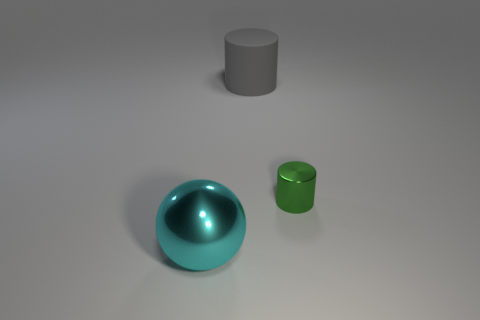How many large objects are either cyan shiny balls or red shiny blocks?
Make the answer very short. 1. What is the color of the small thing?
Offer a terse response. Green. There is a big thing that is behind the metal thing that is to the right of the gray rubber thing; what is its shape?
Offer a terse response. Cylinder. Is there a big cylinder made of the same material as the green object?
Offer a terse response. No. There is a metallic thing behind the cyan sphere; does it have the same size as the big metallic ball?
Give a very brief answer. No. What number of red objects are large matte cylinders or small cylinders?
Your answer should be very brief. 0. What material is the big object that is behind the tiny green shiny cylinder?
Provide a succinct answer. Rubber. What number of green objects are in front of the big thing that is in front of the gray object?
Your answer should be compact. 0. What number of other big matte things have the same shape as the green object?
Ensure brevity in your answer.  1. What number of gray cylinders are there?
Your answer should be very brief. 1. 